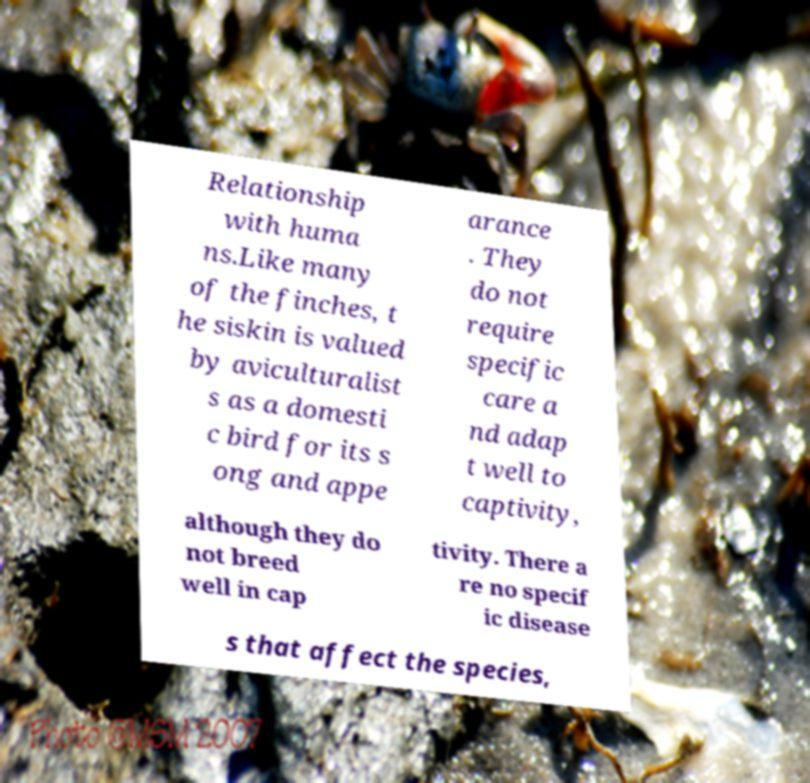Could you assist in decoding the text presented in this image and type it out clearly? Relationship with huma ns.Like many of the finches, t he siskin is valued by aviculturalist s as a domesti c bird for its s ong and appe arance . They do not require specific care a nd adap t well to captivity, although they do not breed well in cap tivity. There a re no specif ic disease s that affect the species, 